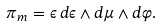Convert formula to latex. <formula><loc_0><loc_0><loc_500><loc_500>\pi _ { m } = \epsilon \, d \epsilon \wedge d \mu \wedge d \varphi .</formula> 